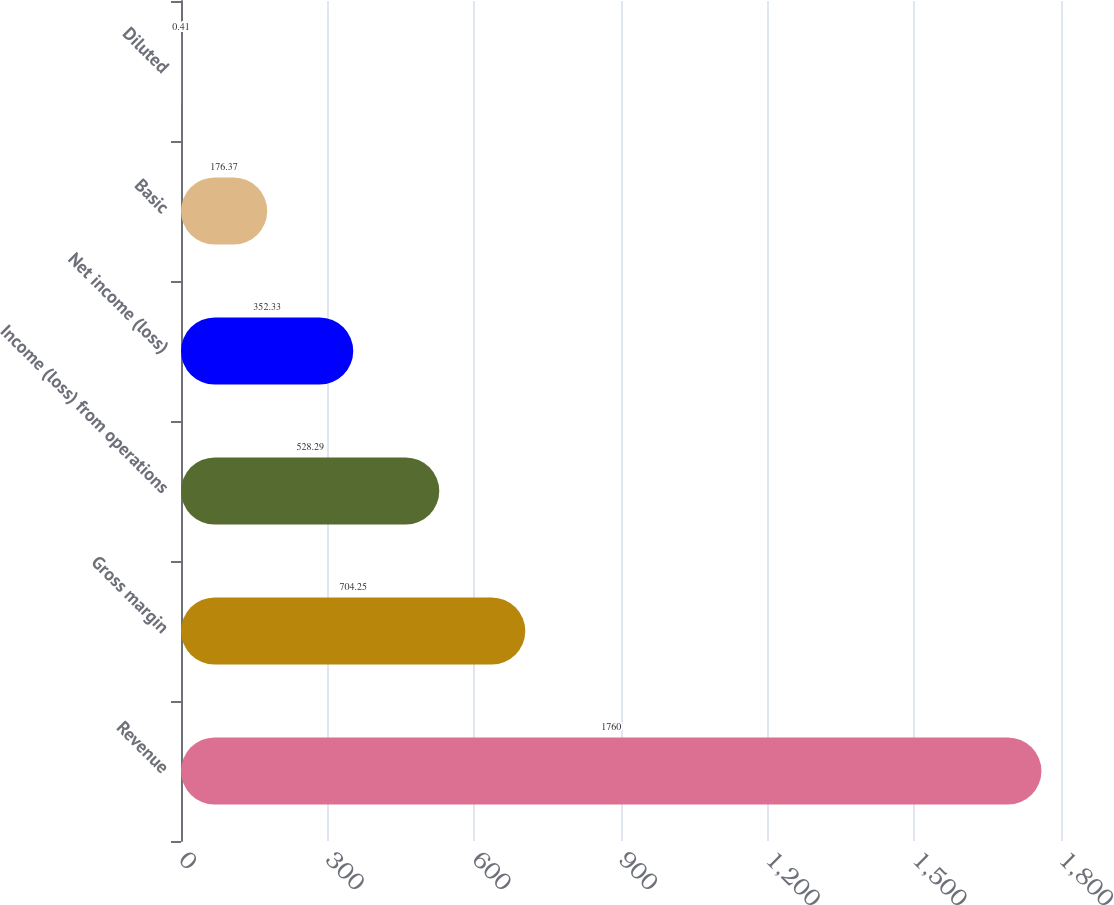Convert chart to OTSL. <chart><loc_0><loc_0><loc_500><loc_500><bar_chart><fcel>Revenue<fcel>Gross margin<fcel>Income (loss) from operations<fcel>Net income (loss)<fcel>Basic<fcel>Diluted<nl><fcel>1760<fcel>704.25<fcel>528.29<fcel>352.33<fcel>176.37<fcel>0.41<nl></chart> 